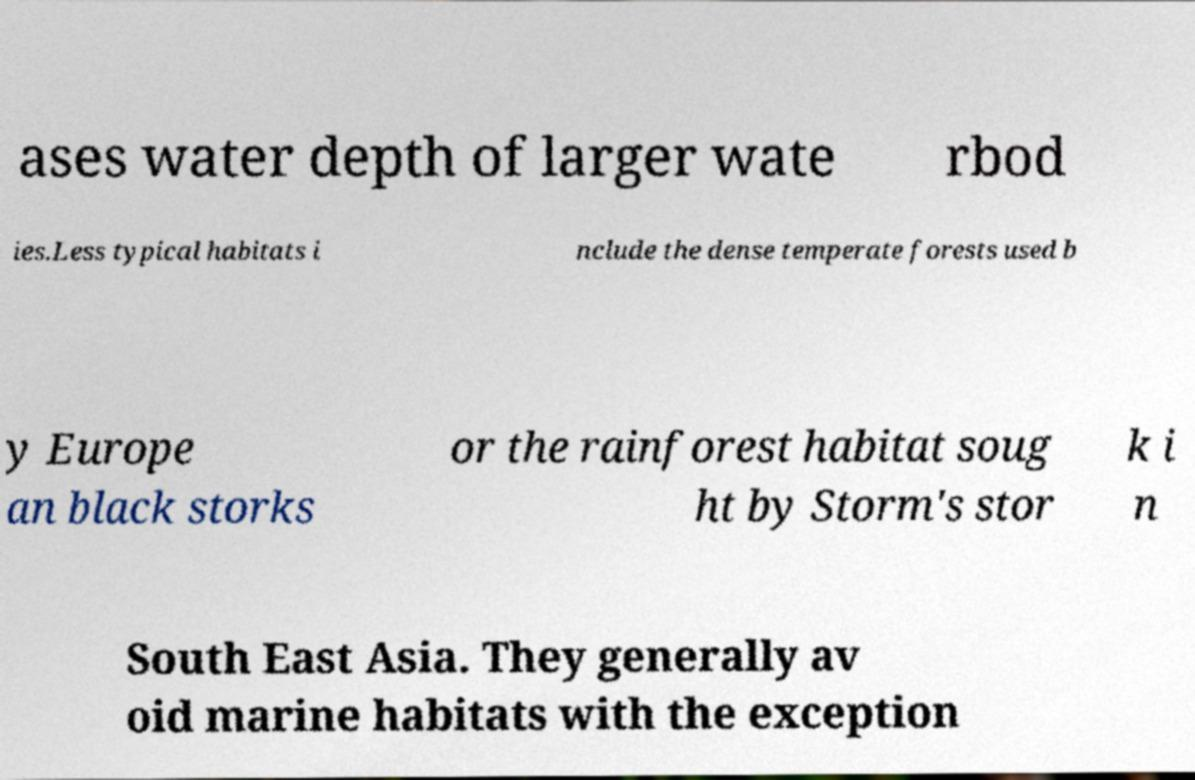There's text embedded in this image that I need extracted. Can you transcribe it verbatim? ases water depth of larger wate rbod ies.Less typical habitats i nclude the dense temperate forests used b y Europe an black storks or the rainforest habitat soug ht by Storm's stor k i n South East Asia. They generally av oid marine habitats with the exception 